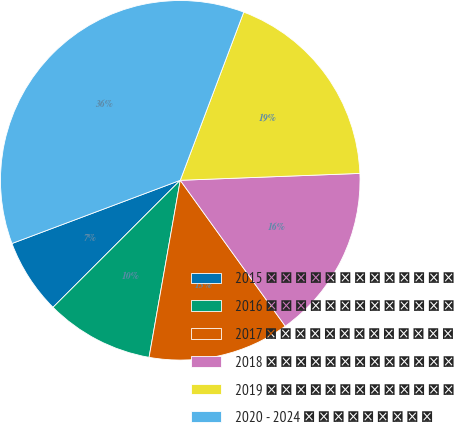Convert chart to OTSL. <chart><loc_0><loc_0><loc_500><loc_500><pie_chart><fcel>2015 � � � � � � � � � � � � �<fcel>2016 � � � � � � � � � � � � �<fcel>2017 � � � � � � � � � � � � �<fcel>2018 � � � � � � � � � � � � �<fcel>2019 � � � � � � � � � � � � �<fcel>2020 - 2024 � � � � � � � � �<nl><fcel>6.77%<fcel>9.74%<fcel>12.71%<fcel>15.68%<fcel>18.65%<fcel>36.47%<nl></chart> 